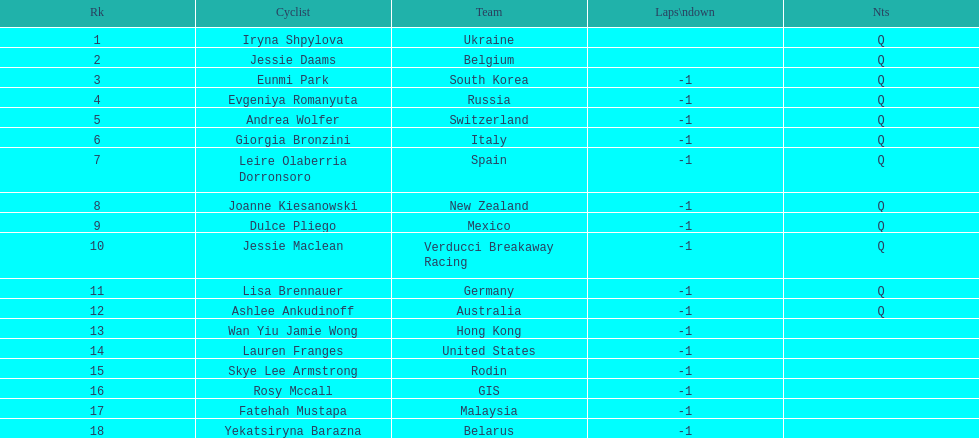Which competitor was the first to end the race one lap behind? Eunmi Park. 